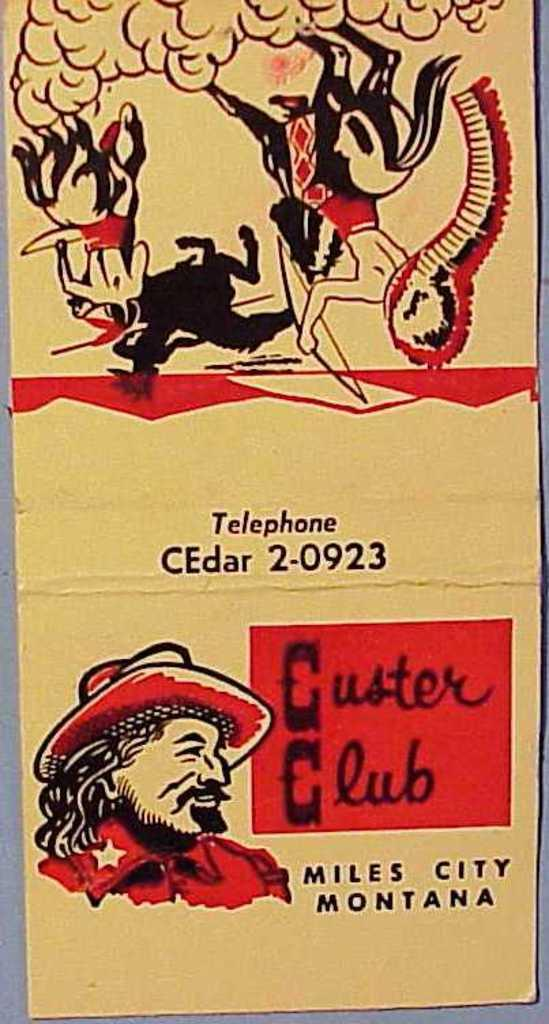What is the main object in the image? There is a card in the image. What type of artwork is featured on the card? The card contains several paintings. Is there any written information on the card? Yes, there is text present on the card. Where is the dirt located on the card in the image? There is no dirt present on the card in the image. What type of shelf is the card placed on in the image? There is no shelf present in the image; the card is not shown to be placed on any surface. 